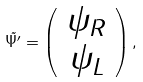Convert formula to latex. <formula><loc_0><loc_0><loc_500><loc_500>\tilde { \Psi ^ { \prime } } = \left ( \begin{array} { c } \psi _ { R } \\ \psi _ { L } \end{array} \right ) ,</formula> 